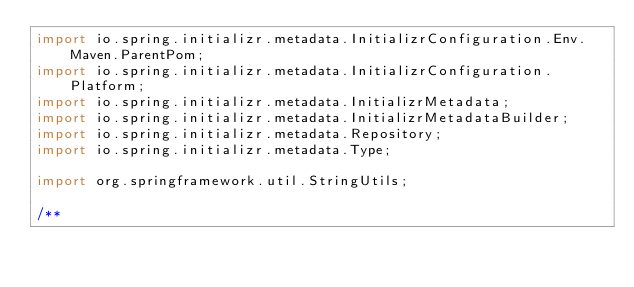Convert code to text. <code><loc_0><loc_0><loc_500><loc_500><_Java_>import io.spring.initializr.metadata.InitializrConfiguration.Env.Maven.ParentPom;
import io.spring.initializr.metadata.InitializrConfiguration.Platform;
import io.spring.initializr.metadata.InitializrMetadata;
import io.spring.initializr.metadata.InitializrMetadataBuilder;
import io.spring.initializr.metadata.Repository;
import io.spring.initializr.metadata.Type;

import org.springframework.util.StringUtils;

/**</code> 